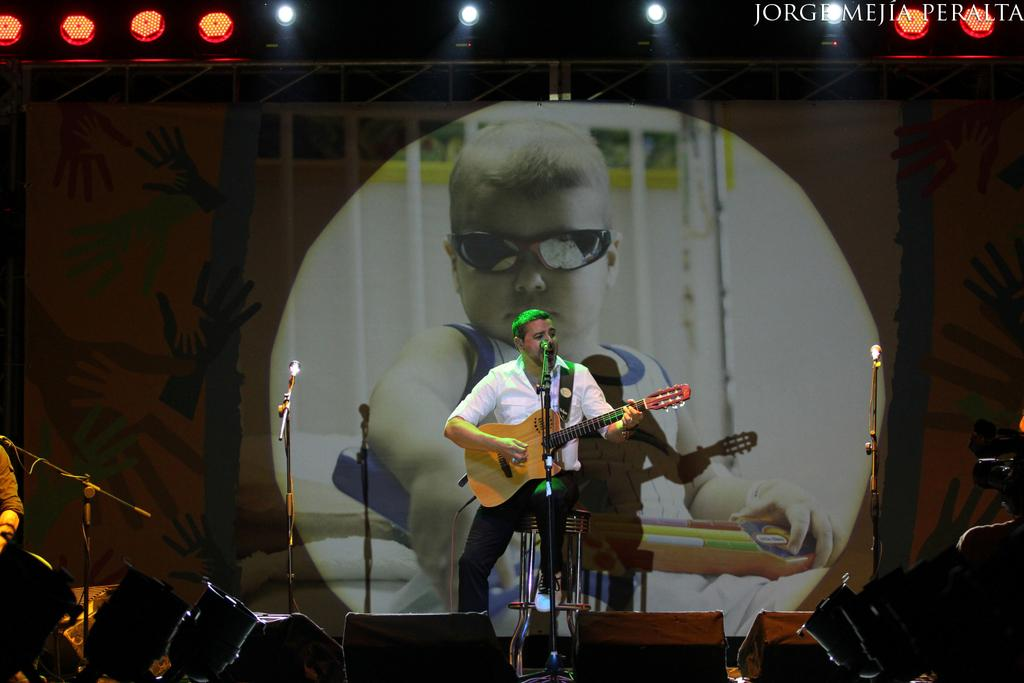What is the man in the image doing? The man is sitting in the image and holding a guitar. What objects are related to the man's activity in the image? Microphones are visible in the image. What can be seen in the background of the image? There is a picture of a boy in the background of the image. What type of brush is the boy using in the image? There is no boy using a brush in the image; the background features a picture of a boy, but no activity is depicted. 